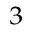Convert formula to latex. <formula><loc_0><loc_0><loc_500><loc_500>_ { 3 }</formula> 